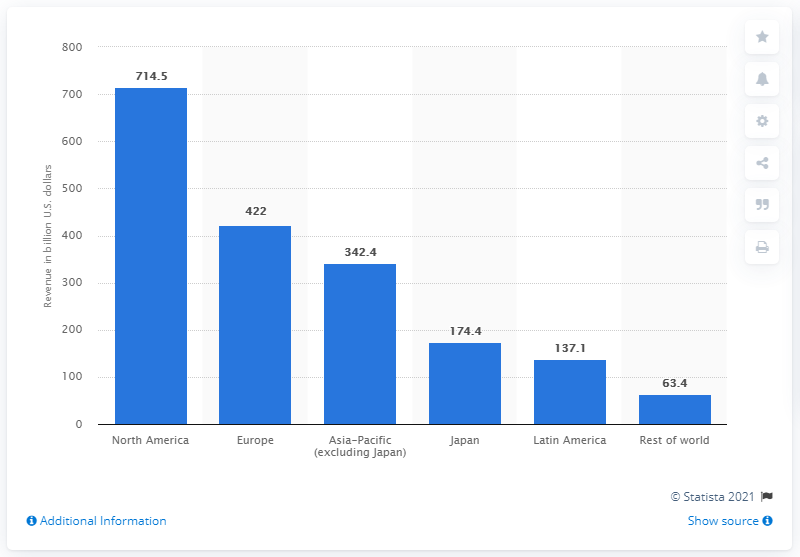List a handful of essential elements in this visual. In 2018, North America is expected to generate approximately 714.5 billion U.S. dollars in health care revenue. 